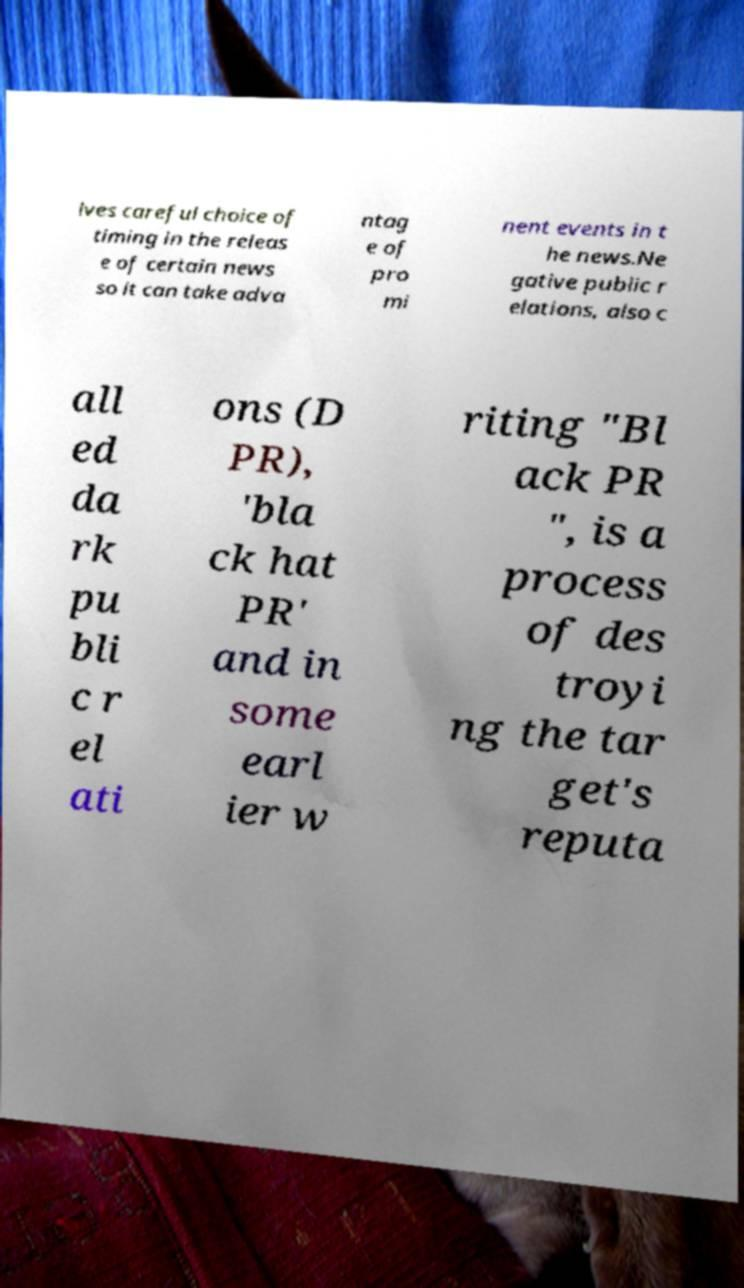Could you assist in decoding the text presented in this image and type it out clearly? lves careful choice of timing in the releas e of certain news so it can take adva ntag e of pro mi nent events in t he news.Ne gative public r elations, also c all ed da rk pu bli c r el ati ons (D PR), 'bla ck hat PR' and in some earl ier w riting "Bl ack PR ", is a process of des troyi ng the tar get's reputa 